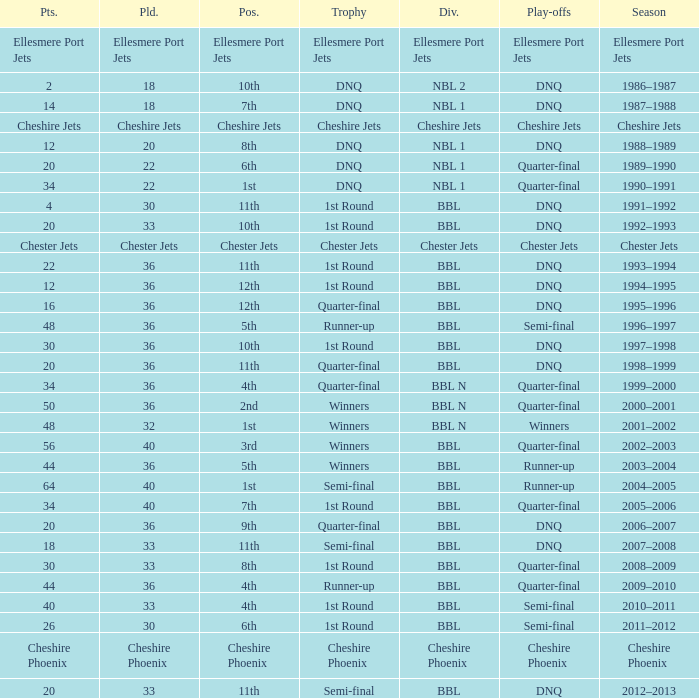During the play-off quarter-final which team scored position was the team that scored 56 points? 3rd. 